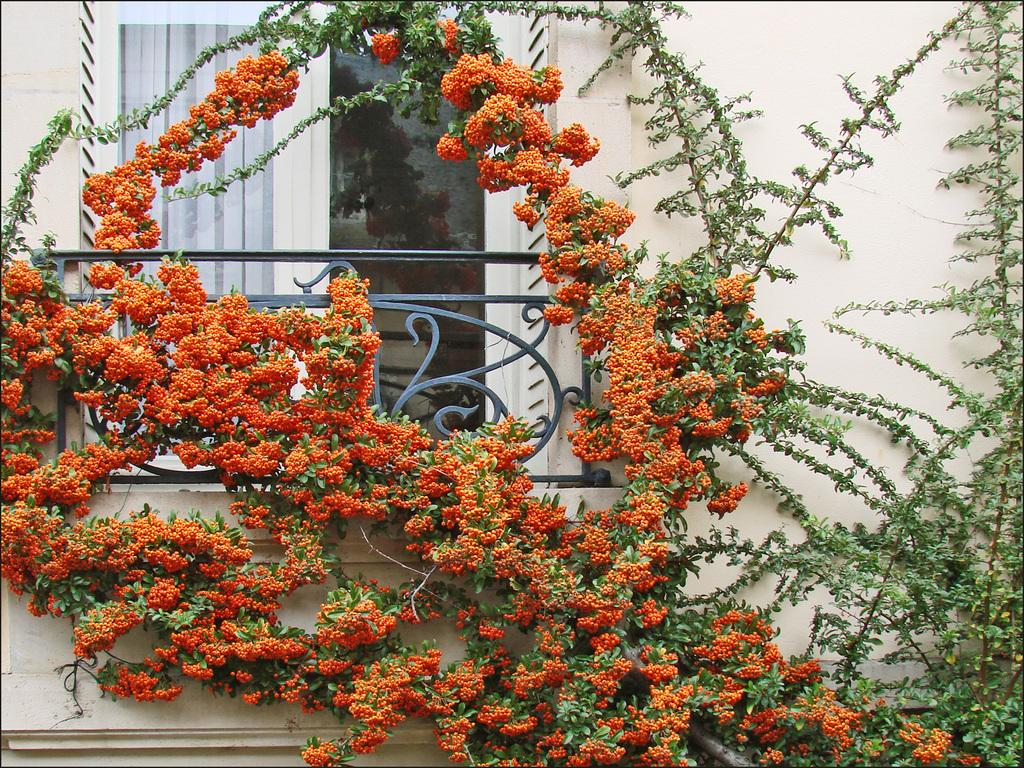What architectural feature can be seen in the image? There is a window in the image. What safety feature is present in the image? There is a railing in the image. What type of structure is visible in the image? There is a wall in the image. What type of vegetation is in front of the wall? There are plants in front of the wall. What color are the flowers on the plants? The flowers on the plants are orange in color. What type of destruction can be seen happening to the wall in the image? There is no destruction present in the image; the wall appears intact. What type of transportation is visible in the image? There are no trains or any other form of transportation visible in the image. What type of sack is being used to carry the plants in the image? There is no sack present in the image; the plants are directly in front of the wall. 